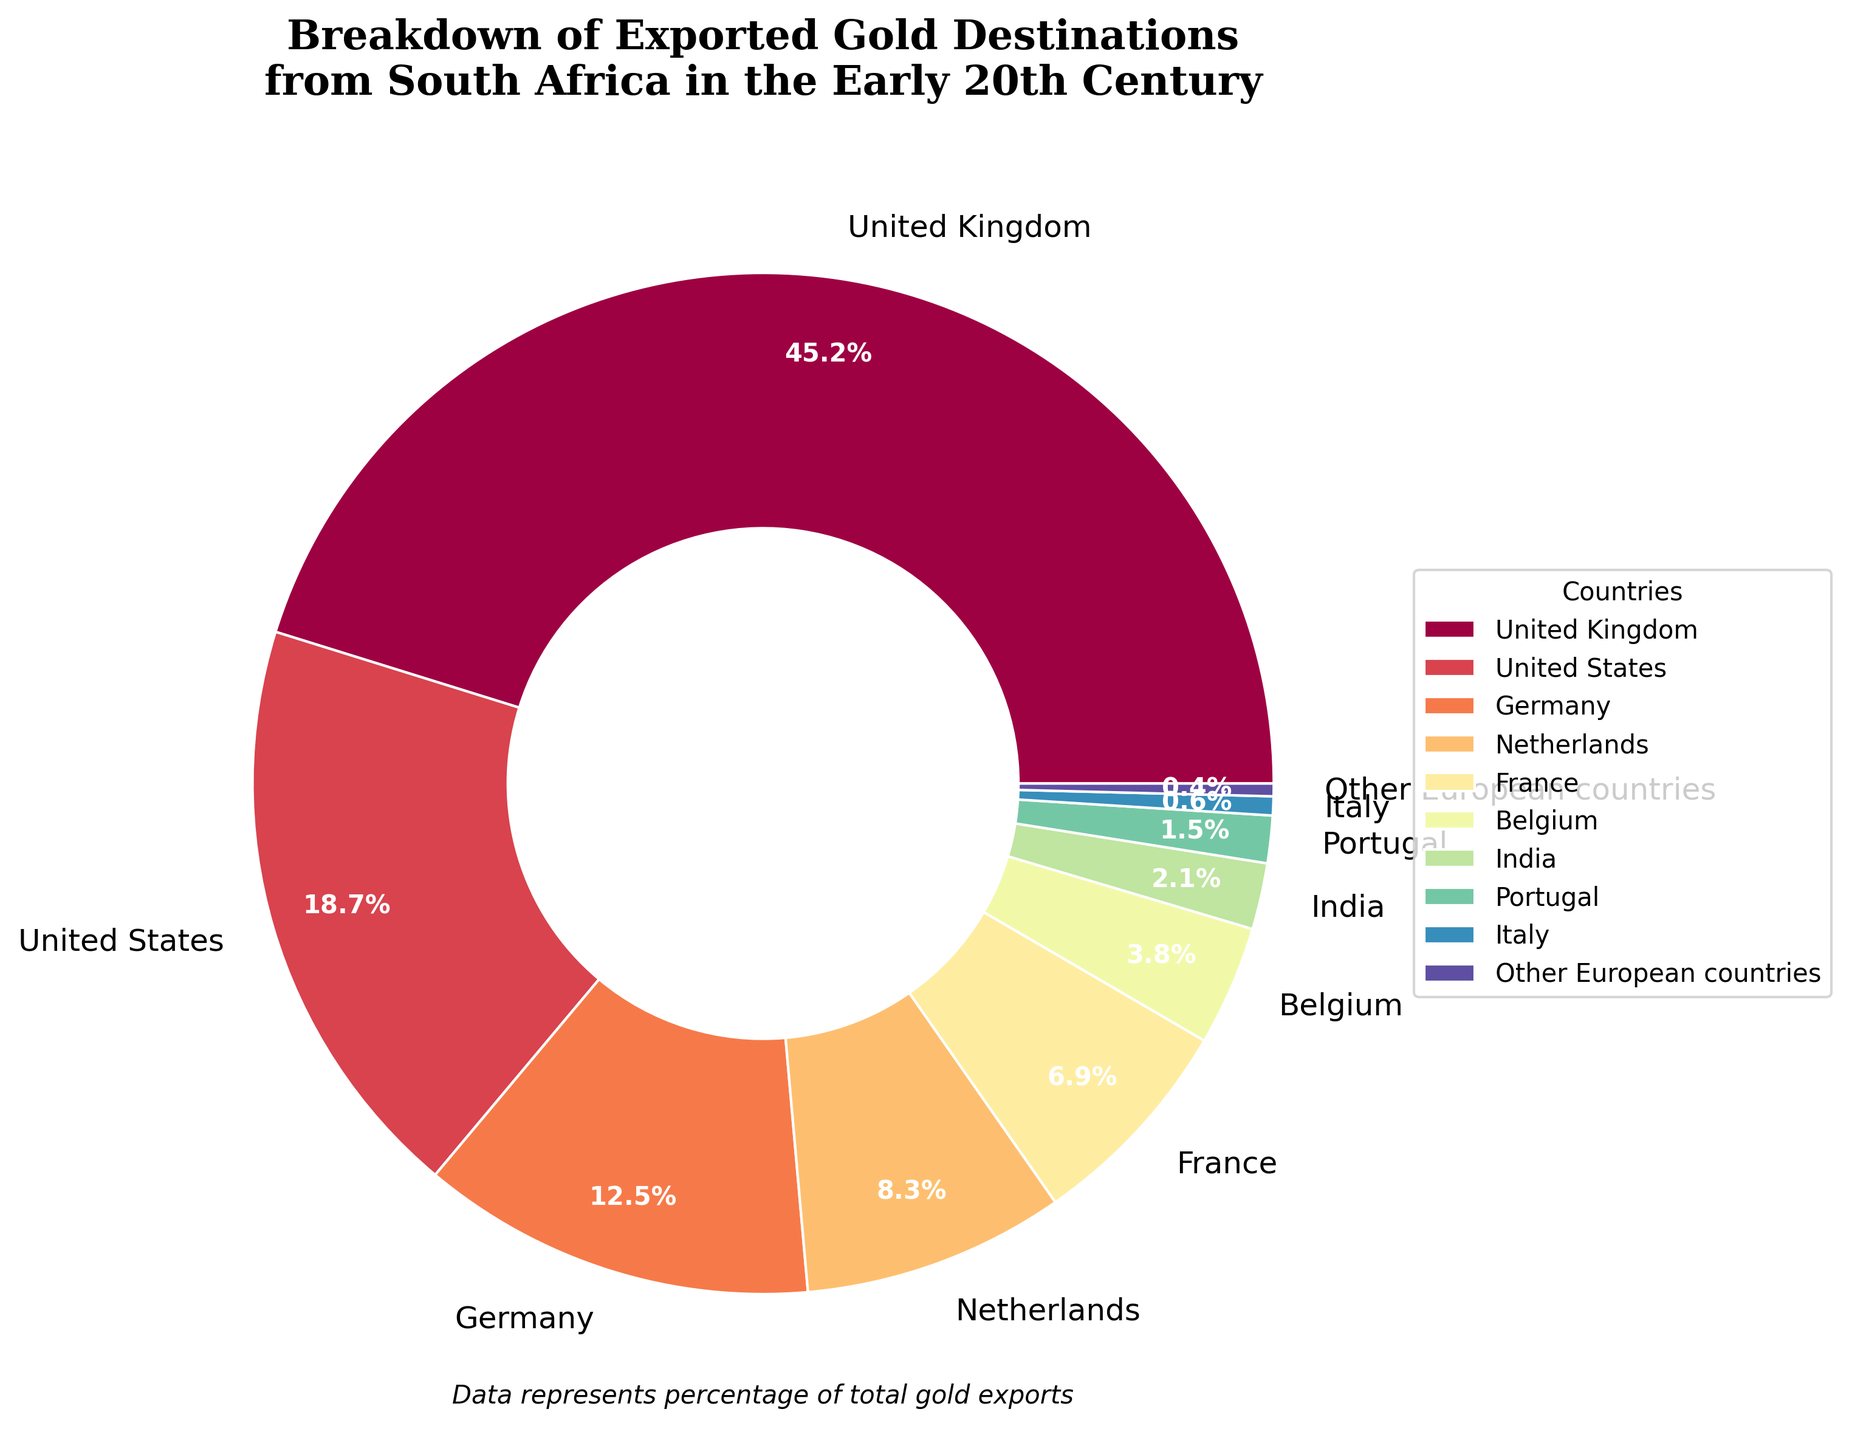What percentage of gold exported from South Africa went to European countries, excluding the United Kingdom? The countries in Europe mentioned are Germany, Netherlands, France, Belgium, Portugal, Italy, and Other European countries. Add their percentages: 12.5 + 8.3 + 6.9 + 3.8 + 1.5 + 0.6 + 0.4 = 34
Answer: 34 Which country received the most gold exports from South Africa? The country with the highest percentage is the United Kingdom at 45.2%.
Answer: United Kingdom How much more gold was exported to the United States compared to Belgium? The percentage exported to the United States is 18.7%, and to Belgium, it's 3.8%. Subtract the smaller from the larger: 18.7 - 3.8 = 14.9
Answer: 14.9 What is the total percentage of gold exports to countries outside of Europe? The countries outside of Europe mentioned are the United States and India. Adding their percentages: 18.7 + 2.1 = 20.8
Answer: 20.8 How does the percentage of gold exports to France compare to Germany? France has 6.9%, and Germany has 12.5%. Germany's percentage is higher.
Answer: Germany What is the average percentage of gold exports to the Netherlands, Spain, and Portugal? Spain is not listed; the question should focus on Germany, France, and Portugal. Calculate the average: (8.3 + 6.9 + 1.5) / 3 = 16.7/3 = 5.57
Answer: 5.57 Is the percentage exported to the United Kingdom more than the combined percentage of the United States and Germany? United Kingdom: 45.2%, United States + Germany: 18.7 + 12.5 = 31.2%. 45.2% is greater than 31.2%.
Answer: Yes Which countries received less than 1% of the gold exports? The chart shows that only one country, Other European countries, received 0.4%. Italy just above this, at 0.6%. Therefore, Other European countries received the least.
Answer: Other European countries 